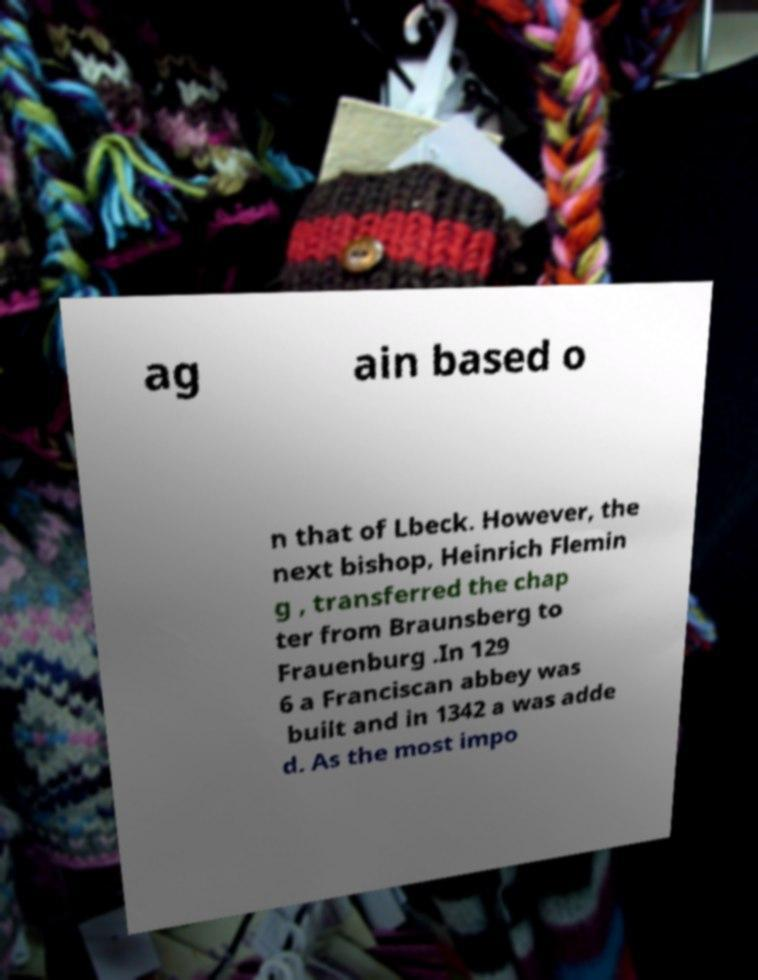What messages or text are displayed in this image? I need them in a readable, typed format. ag ain based o n that of Lbeck. However, the next bishop, Heinrich Flemin g , transferred the chap ter from Braunsberg to Frauenburg .In 129 6 a Franciscan abbey was built and in 1342 a was adde d. As the most impo 